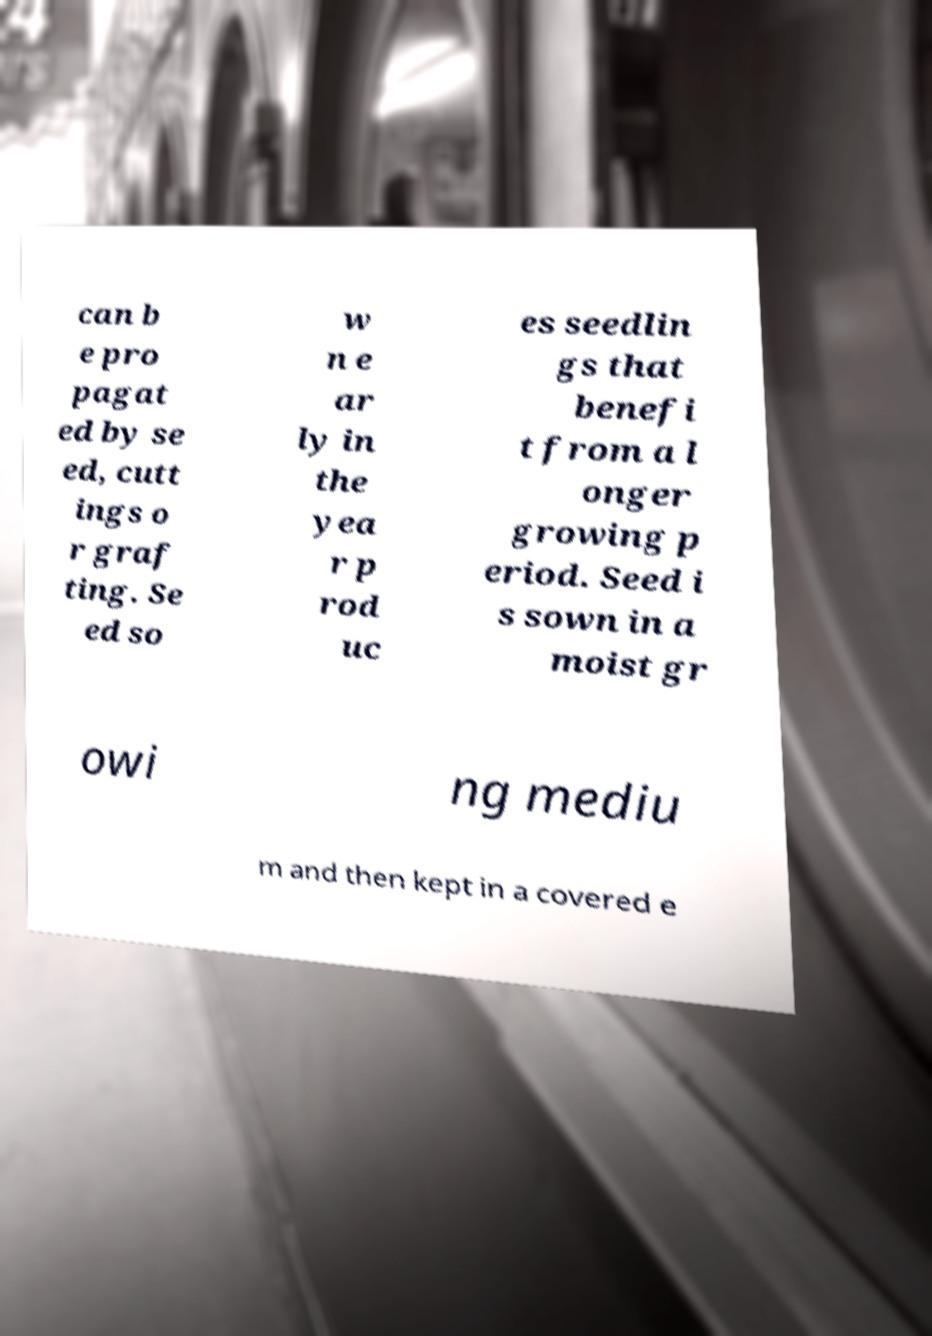What messages or text are displayed in this image? I need them in a readable, typed format. can b e pro pagat ed by se ed, cutt ings o r graf ting. Se ed so w n e ar ly in the yea r p rod uc es seedlin gs that benefi t from a l onger growing p eriod. Seed i s sown in a moist gr owi ng mediu m and then kept in a covered e 